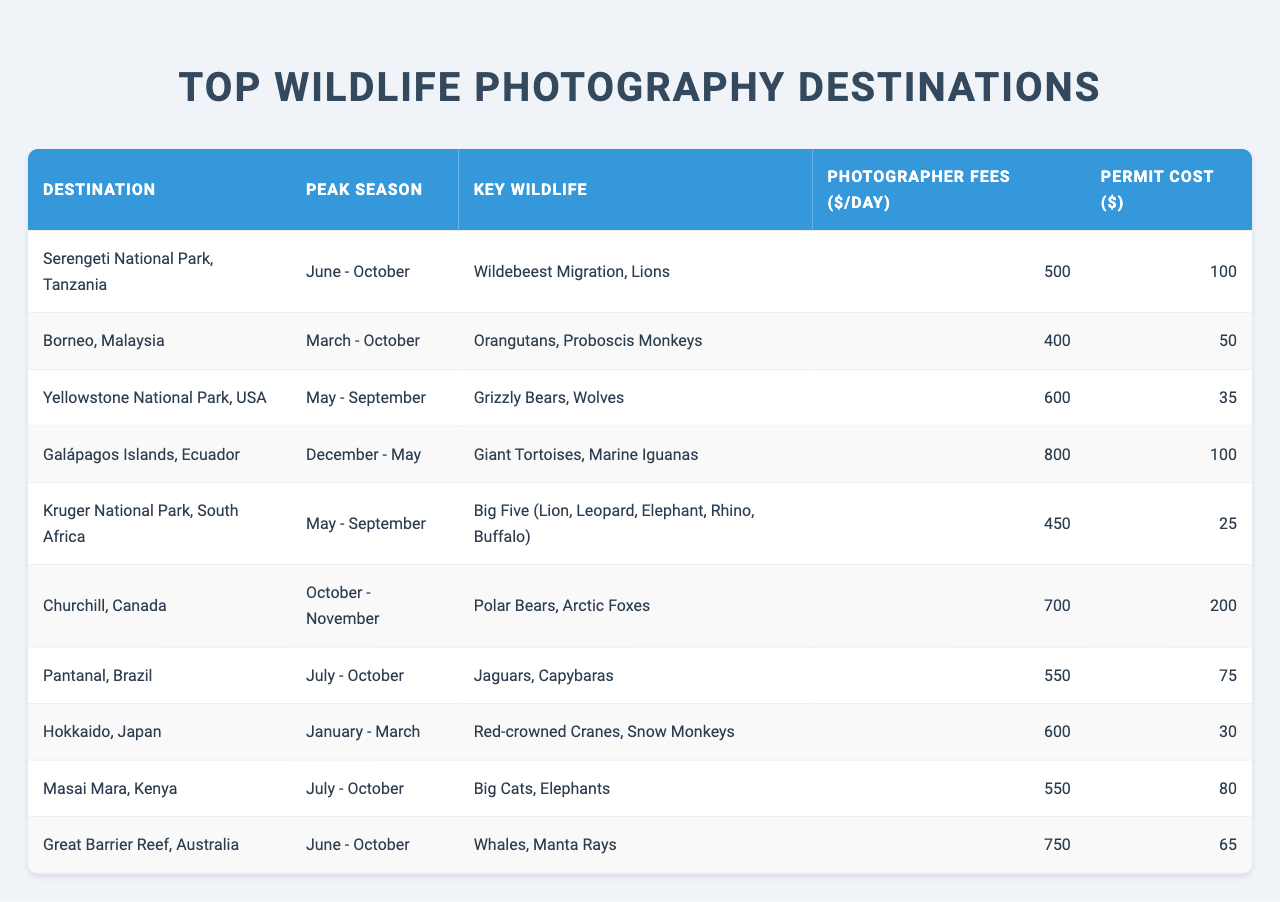What is the peak season for the Serengeti National Park? The table lists "June - October" as the peak season for the Serengeti National Park.
Answer: June - October Which destination has the highest photographer fees per day? By comparing the photographer fees listed in the table, Galápagos Islands has the highest fee of $800 per day.
Answer: $800 What is the total cost (photographer fees plus permit cost) for wildlife photography in Kruger National Park? The photographer fee for Kruger National Park is $450 and the permit cost is $25, so the total cost is $450 + $25 = $475.
Answer: $475 Is the photographer fee for Borneo, Malaysia greater than that for Pantanal, Brazil? Borneo has a fee of $400 and Pantanal has a fee of $550. Since $400 is less than $550, the statement is false.
Answer: No What is the average permit cost for all the listed destinations? The permit costs are: 100, 50, 35, 100, 25, 200, 75, 30, 80, 65. Adding them gives 100 + 50 + 35 + 100 + 25 + 200 + 75 + 30 + 80 + 65 = 760. There are 10 destinations, so the average is 760 / 10 = 76.
Answer: 76 Which destination has the same peak season as Masai Mara, Kenya? Both Masai Mara and Pantanal have a peak season of July - October, as indicated in the table.
Answer: Pantanal, Brazil What is the total photographer fee for the three destinations with the highest fees? The three highest fees are Galápagos Islands ($800), Great Barrier Reef ($750), and Churchill ($700). Summing these gives $800 + $750 + $700 = $2250.
Answer: $2250 Is Churchill, Canada known for Jaguars? The table indicates that Churchill is known for Polar Bears and Arctic Foxes, while Jaguars are listed under Pantanal, Brazil, making the statement false.
Answer: No Which destination has the least expensive permit cost? By examining the permit costs, Kruger National Park has the least expensive permit cost at $25.
Answer: Kruger National Park If you wanted to photograph Giant Tortoises, which destination would you go to? The table shows that Giant Tortoises can be photographed at Galápagos Islands, so that would be the destination to go to.
Answer: Galápagos Islands 